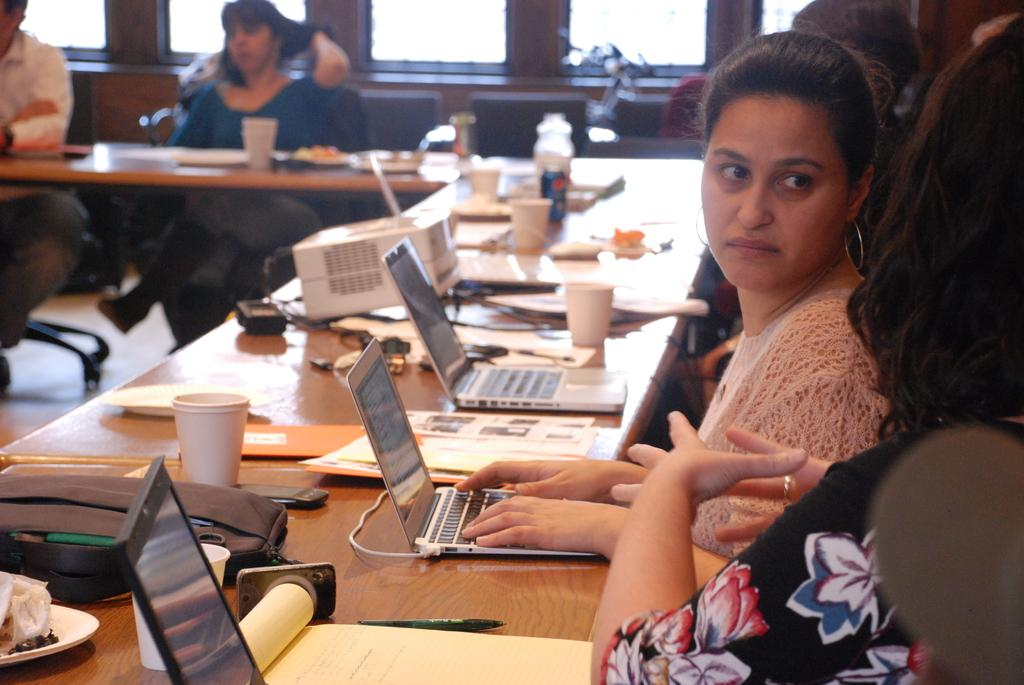What electronic device is on the table in the image? There is a laptop on the table in the image. What other objects are on the table? There is a glass, a projector, a bottle, a book, and a pen on the table. What is the woman in the image doing? The woman is using the laptop. Can you describe the background of the image? There is a glass and a chair in the background. How many objects are on the table? There are six objects on the table: a laptop, a glass, a projector, a bottle, a book, and a pen. What type of vessel is sailing in the background of the image? There is no vessel present in the background of the image. Is there an island visible in the image? No, there is no island visible in the image. 